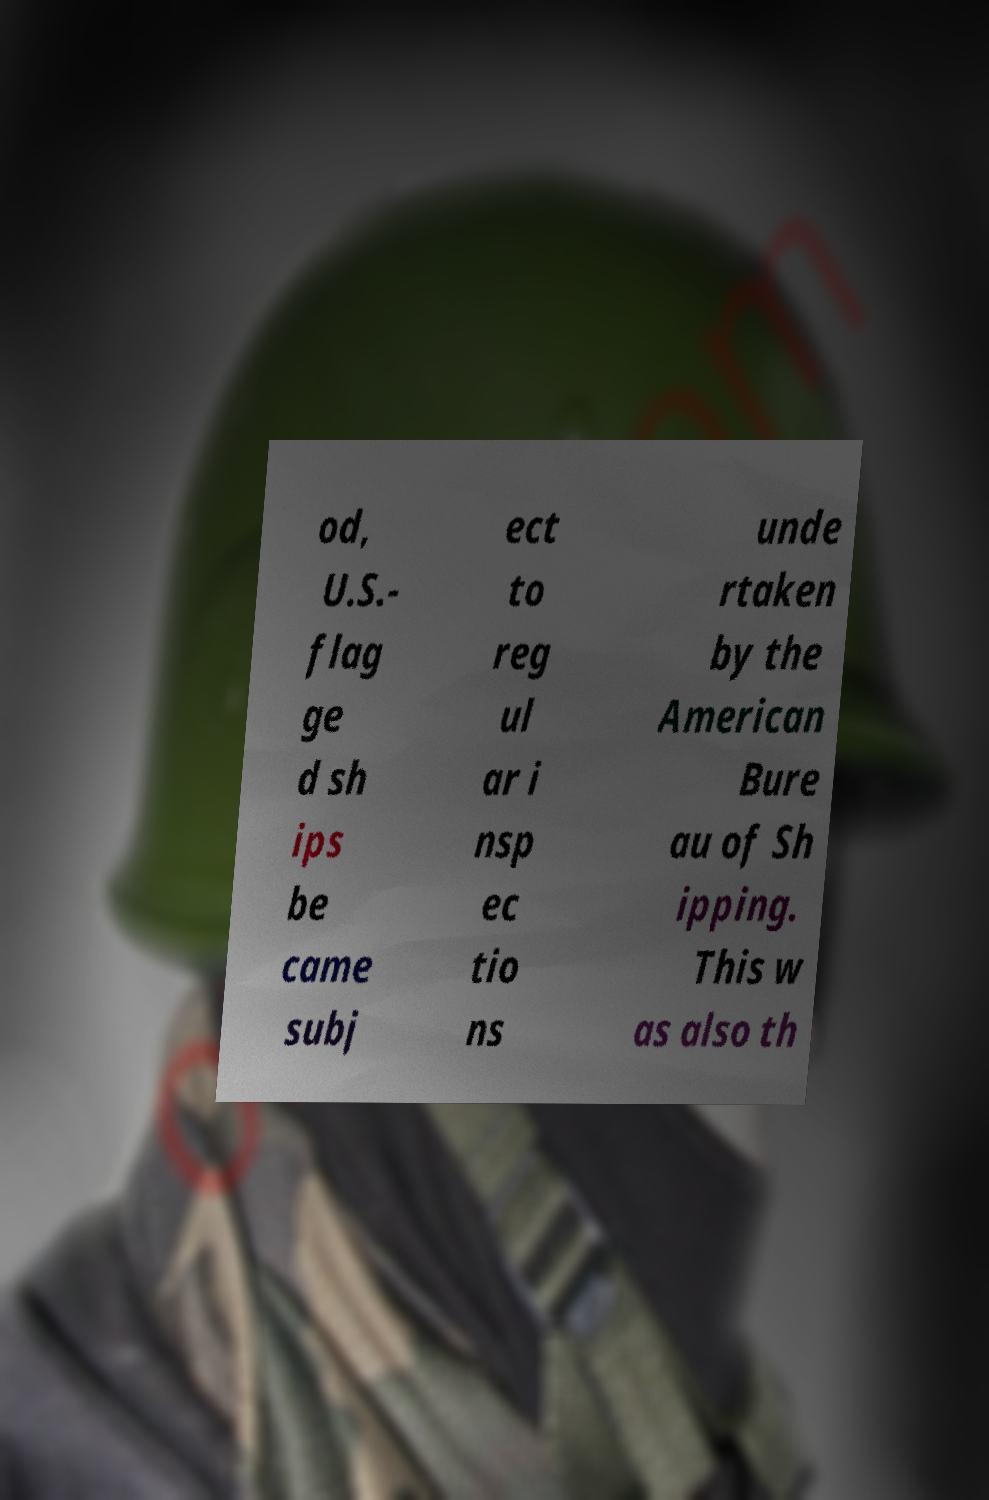I need the written content from this picture converted into text. Can you do that? od, U.S.- flag ge d sh ips be came subj ect to reg ul ar i nsp ec tio ns unde rtaken by the American Bure au of Sh ipping. This w as also th 